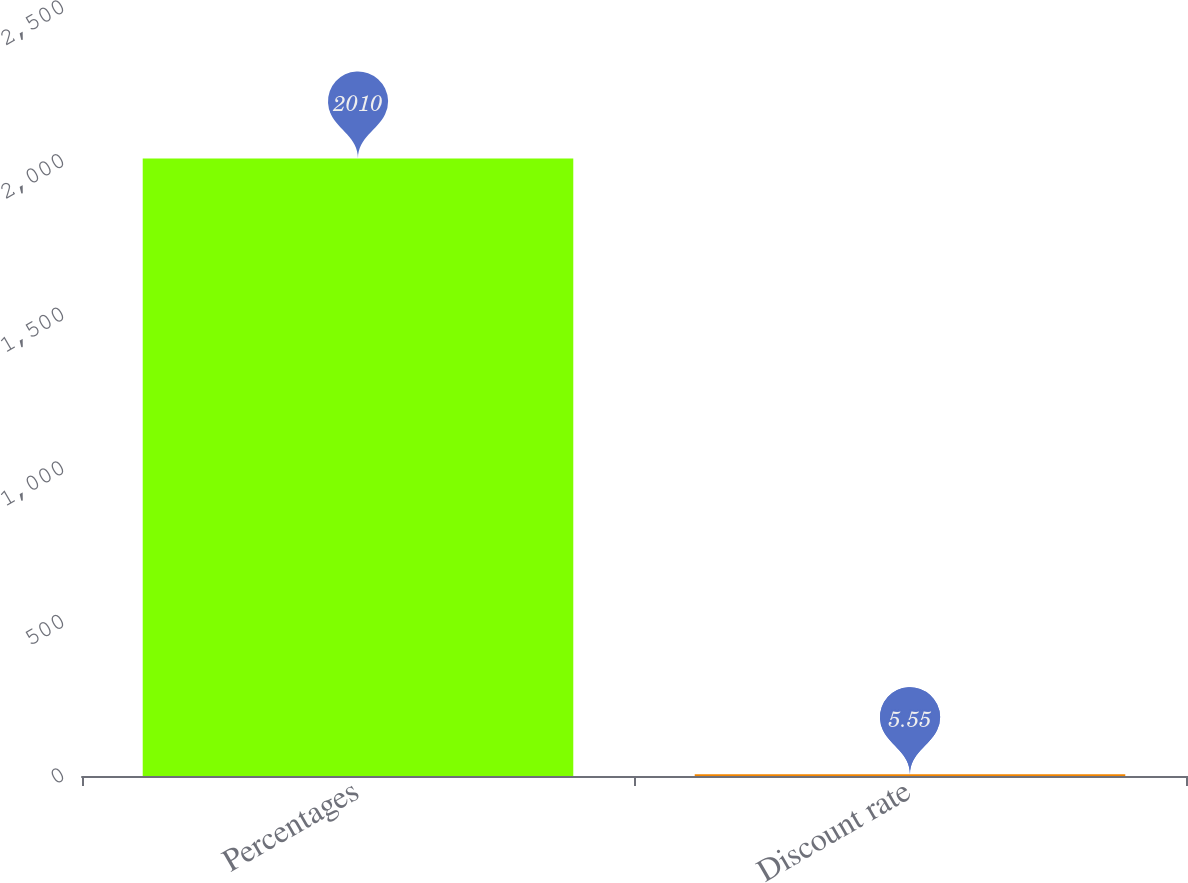Convert chart. <chart><loc_0><loc_0><loc_500><loc_500><bar_chart><fcel>Percentages<fcel>Discount rate<nl><fcel>2010<fcel>5.55<nl></chart> 